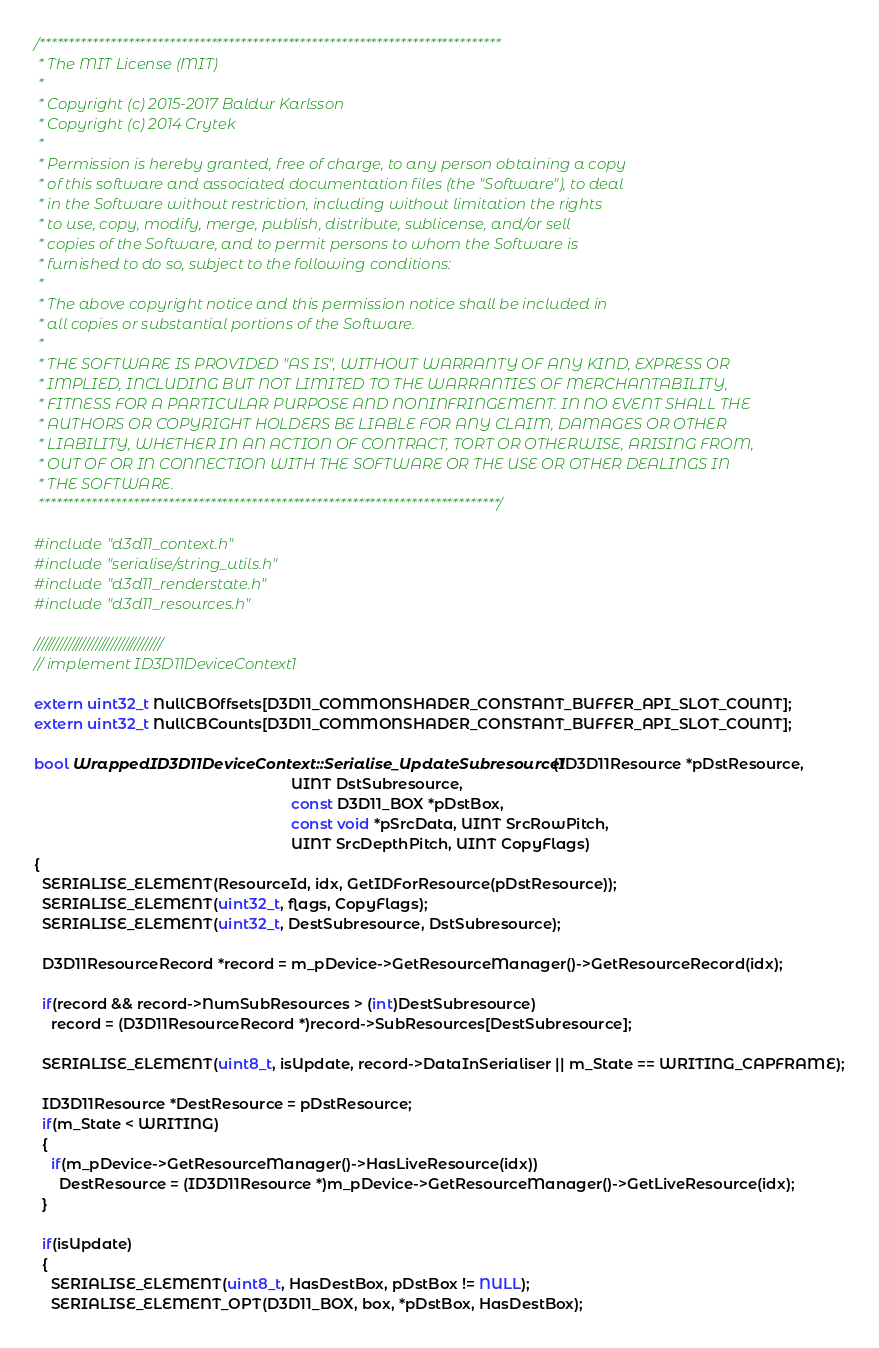Convert code to text. <code><loc_0><loc_0><loc_500><loc_500><_C++_>/******************************************************************************
 * The MIT License (MIT)
 *
 * Copyright (c) 2015-2017 Baldur Karlsson
 * Copyright (c) 2014 Crytek
 *
 * Permission is hereby granted, free of charge, to any person obtaining a copy
 * of this software and associated documentation files (the "Software"), to deal
 * in the Software without restriction, including without limitation the rights
 * to use, copy, modify, merge, publish, distribute, sublicense, and/or sell
 * copies of the Software, and to permit persons to whom the Software is
 * furnished to do so, subject to the following conditions:
 *
 * The above copyright notice and this permission notice shall be included in
 * all copies or substantial portions of the Software.
 *
 * THE SOFTWARE IS PROVIDED "AS IS", WITHOUT WARRANTY OF ANY KIND, EXPRESS OR
 * IMPLIED, INCLUDING BUT NOT LIMITED TO THE WARRANTIES OF MERCHANTABILITY,
 * FITNESS FOR A PARTICULAR PURPOSE AND NONINFRINGEMENT. IN NO EVENT SHALL THE
 * AUTHORS OR COPYRIGHT HOLDERS BE LIABLE FOR ANY CLAIM, DAMAGES OR OTHER
 * LIABILITY, WHETHER IN AN ACTION OF CONTRACT, TORT OR OTHERWISE, ARISING FROM,
 * OUT OF OR IN CONNECTION WITH THE SOFTWARE OR THE USE OR OTHER DEALINGS IN
 * THE SOFTWARE.
 ******************************************************************************/

#include "d3d11_context.h"
#include "serialise/string_utils.h"
#include "d3d11_renderstate.h"
#include "d3d11_resources.h"

/////////////////////////////////
// implement ID3D11DeviceContext1

extern uint32_t NullCBOffsets[D3D11_COMMONSHADER_CONSTANT_BUFFER_API_SLOT_COUNT];
extern uint32_t NullCBCounts[D3D11_COMMONSHADER_CONSTANT_BUFFER_API_SLOT_COUNT];

bool WrappedID3D11DeviceContext::Serialise_UpdateSubresource1(ID3D11Resource *pDstResource,
                                                              UINT DstSubresource,
                                                              const D3D11_BOX *pDstBox,
                                                              const void *pSrcData, UINT SrcRowPitch,
                                                              UINT SrcDepthPitch, UINT CopyFlags)
{
  SERIALISE_ELEMENT(ResourceId, idx, GetIDForResource(pDstResource));
  SERIALISE_ELEMENT(uint32_t, flags, CopyFlags);
  SERIALISE_ELEMENT(uint32_t, DestSubresource, DstSubresource);

  D3D11ResourceRecord *record = m_pDevice->GetResourceManager()->GetResourceRecord(idx);

  if(record && record->NumSubResources > (int)DestSubresource)
    record = (D3D11ResourceRecord *)record->SubResources[DestSubresource];

  SERIALISE_ELEMENT(uint8_t, isUpdate, record->DataInSerialiser || m_State == WRITING_CAPFRAME);

  ID3D11Resource *DestResource = pDstResource;
  if(m_State < WRITING)
  {
    if(m_pDevice->GetResourceManager()->HasLiveResource(idx))
      DestResource = (ID3D11Resource *)m_pDevice->GetResourceManager()->GetLiveResource(idx);
  }

  if(isUpdate)
  {
    SERIALISE_ELEMENT(uint8_t, HasDestBox, pDstBox != NULL);
    SERIALISE_ELEMENT_OPT(D3D11_BOX, box, *pDstBox, HasDestBox);</code> 